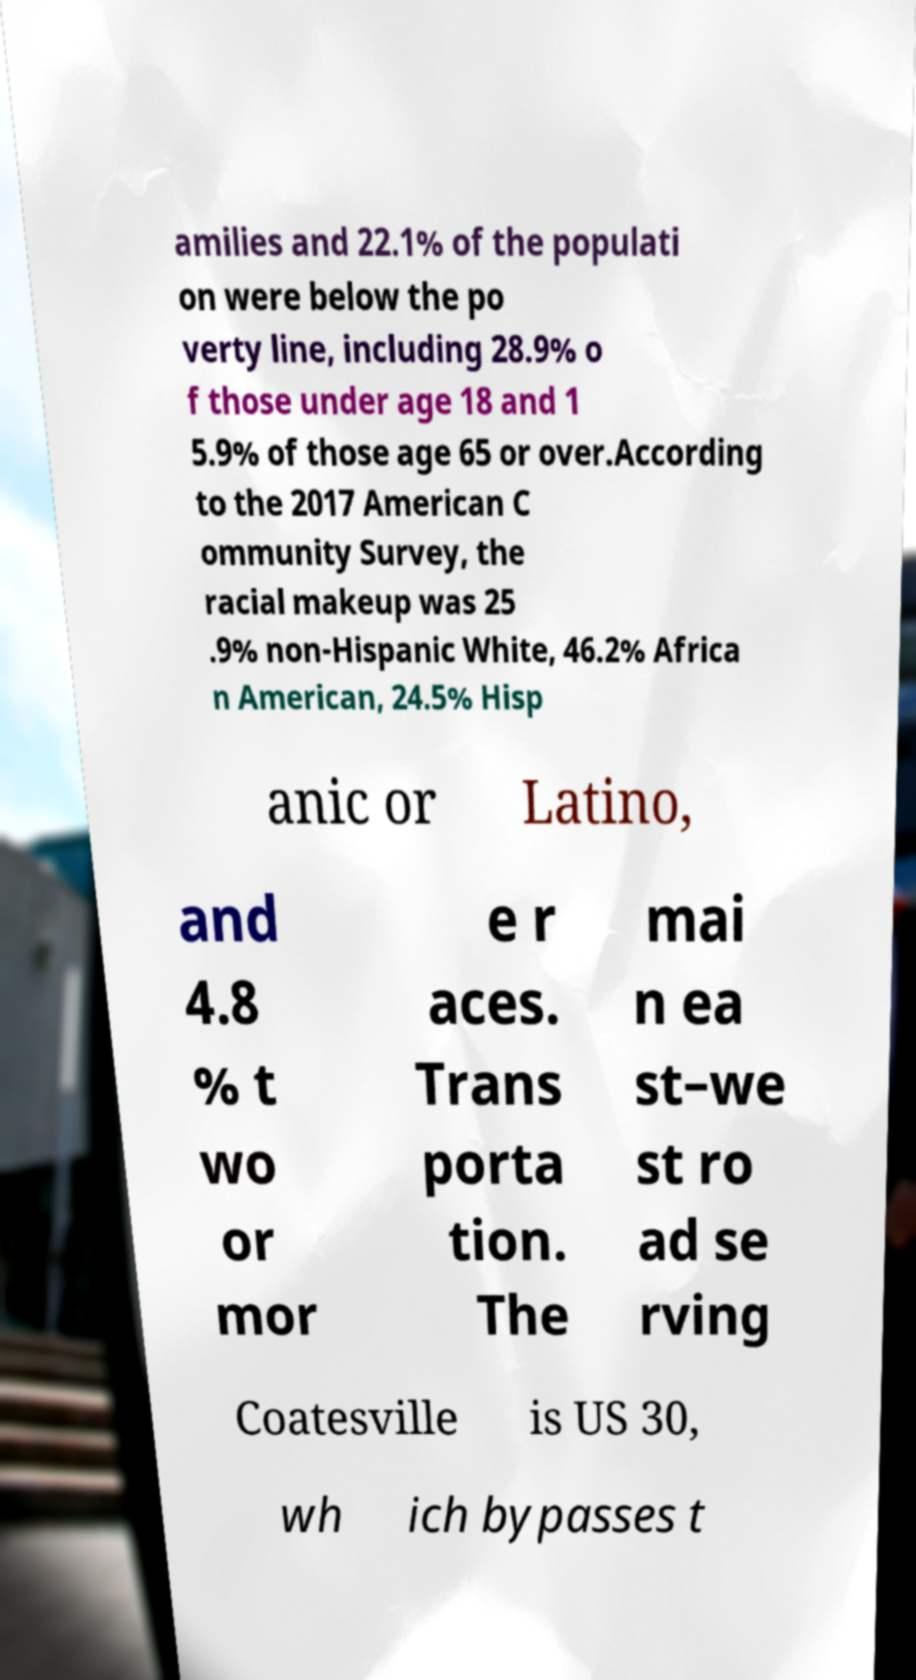There's text embedded in this image that I need extracted. Can you transcribe it verbatim? amilies and 22.1% of the populati on were below the po verty line, including 28.9% o f those under age 18 and 1 5.9% of those age 65 or over.According to the 2017 American C ommunity Survey, the racial makeup was 25 .9% non-Hispanic White, 46.2% Africa n American, 24.5% Hisp anic or Latino, and 4.8 % t wo or mor e r aces. Trans porta tion. The mai n ea st–we st ro ad se rving Coatesville is US 30, wh ich bypasses t 